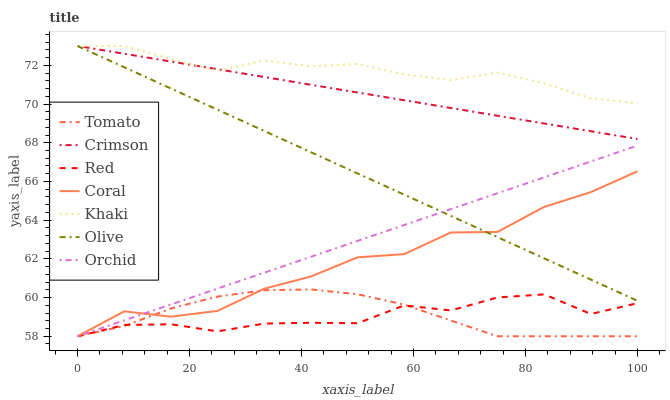Does Red have the minimum area under the curve?
Answer yes or no. Yes. Does Khaki have the maximum area under the curve?
Answer yes or no. Yes. Does Coral have the minimum area under the curve?
Answer yes or no. No. Does Coral have the maximum area under the curve?
Answer yes or no. No. Is Orchid the smoothest?
Answer yes or no. Yes. Is Coral the roughest?
Answer yes or no. Yes. Is Khaki the smoothest?
Answer yes or no. No. Is Khaki the roughest?
Answer yes or no. No. Does Khaki have the lowest value?
Answer yes or no. No. Does Crimson have the highest value?
Answer yes or no. Yes. Does Coral have the highest value?
Answer yes or no. No. Is Red less than Crimson?
Answer yes or no. Yes. Is Khaki greater than Tomato?
Answer yes or no. Yes. Does Coral intersect Tomato?
Answer yes or no. Yes. Is Coral less than Tomato?
Answer yes or no. No. Is Coral greater than Tomato?
Answer yes or no. No. Does Red intersect Crimson?
Answer yes or no. No. 